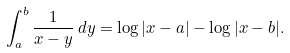<formula> <loc_0><loc_0><loc_500><loc_500>\int _ { a } ^ { b } \frac { 1 } { x - y } \, d y = \log | x - a | - \log | x - b | .</formula> 